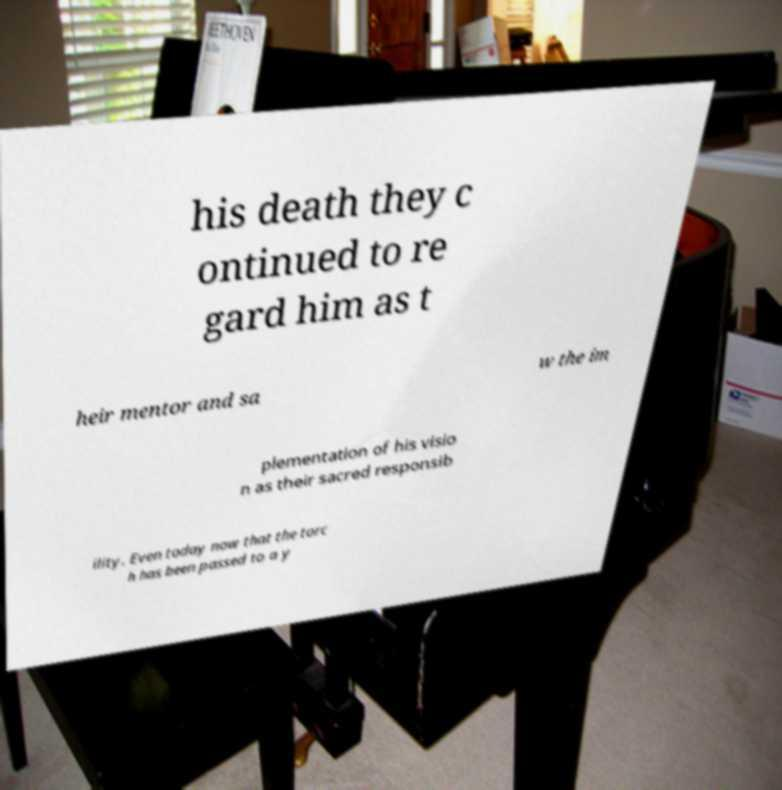Please identify and transcribe the text found in this image. his death they c ontinued to re gard him as t heir mentor and sa w the im plementation of his visio n as their sacred responsib ility. Even today now that the torc h has been passed to a y 